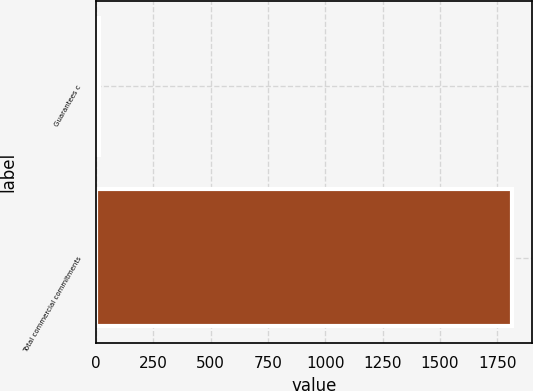<chart> <loc_0><loc_0><loc_500><loc_500><bar_chart><fcel>Guarantees c<fcel>Total commercial commitments<nl><fcel>12<fcel>1812<nl></chart> 